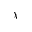<formula> <loc_0><loc_0><loc_500><loc_500>\chi</formula> 